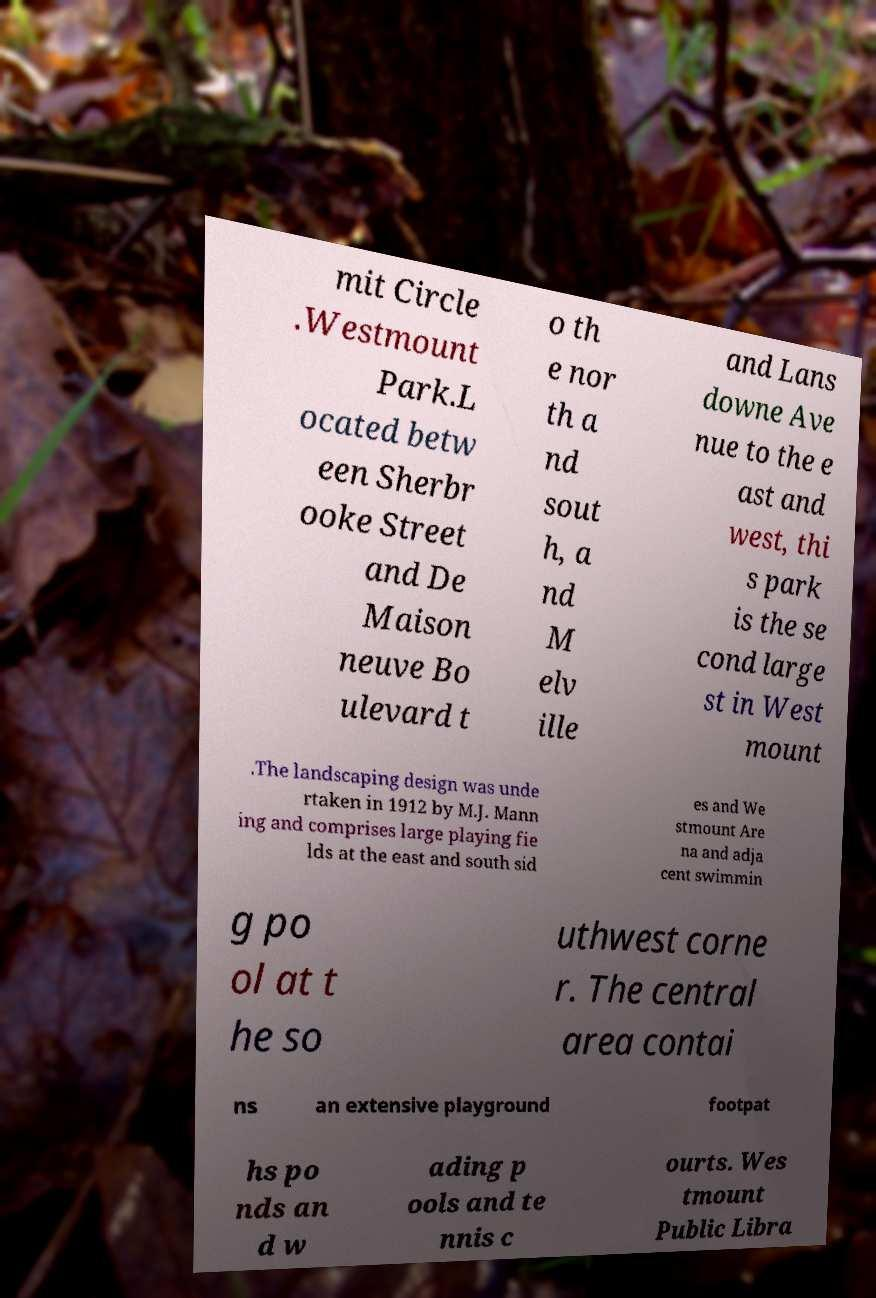Could you assist in decoding the text presented in this image and type it out clearly? mit Circle .Westmount Park.L ocated betw een Sherbr ooke Street and De Maison neuve Bo ulevard t o th e nor th a nd sout h, a nd M elv ille and Lans downe Ave nue to the e ast and west, thi s park is the se cond large st in West mount .The landscaping design was unde rtaken in 1912 by M.J. Mann ing and comprises large playing fie lds at the east and south sid es and We stmount Are na and adja cent swimmin g po ol at t he so uthwest corne r. The central area contai ns an extensive playground footpat hs po nds an d w ading p ools and te nnis c ourts. Wes tmount Public Libra 